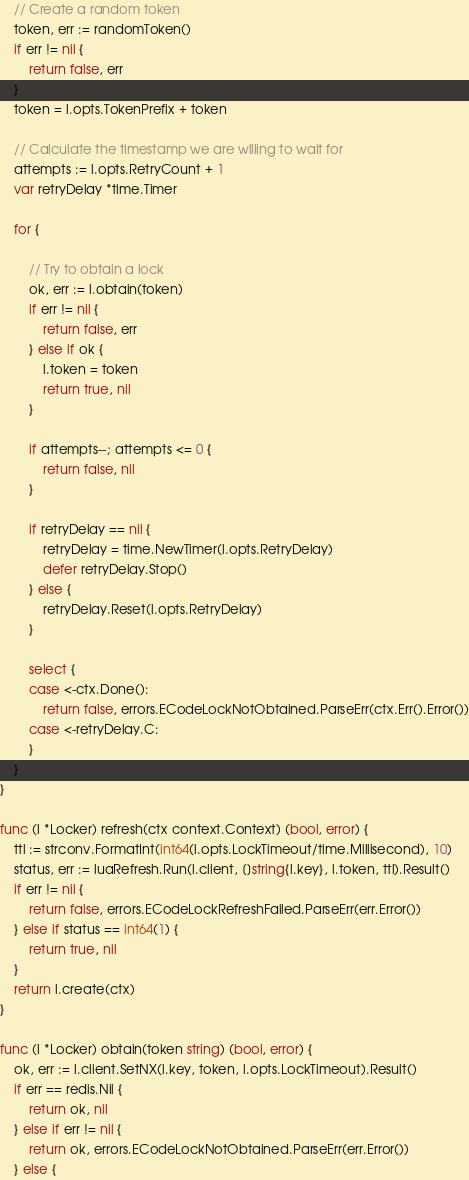<code> <loc_0><loc_0><loc_500><loc_500><_Go_>	// Create a random token
	token, err := randomToken()
	if err != nil {
		return false, err
	}
	token = l.opts.TokenPrefix + token

	// Calculate the timestamp we are willing to wait for
	attempts := l.opts.RetryCount + 1
	var retryDelay *time.Timer

	for {

		// Try to obtain a lock
		ok, err := l.obtain(token)
		if err != nil {
			return false, err
		} else if ok {
			l.token = token
			return true, nil
		}

		if attempts--; attempts <= 0 {
			return false, nil
		}

		if retryDelay == nil {
			retryDelay = time.NewTimer(l.opts.RetryDelay)
			defer retryDelay.Stop()
		} else {
			retryDelay.Reset(l.opts.RetryDelay)
		}

		select {
		case <-ctx.Done():
			return false, errors.ECodeLockNotObtained.ParseErr(ctx.Err().Error())
		case <-retryDelay.C:
		}
	}
}

func (l *Locker) refresh(ctx context.Context) (bool, error) {
	ttl := strconv.FormatInt(int64(l.opts.LockTimeout/time.Millisecond), 10)
	status, err := luaRefresh.Run(l.client, []string{l.key}, l.token, ttl).Result()
	if err != nil {
		return false, errors.ECodeLockRefreshFailed.ParseErr(err.Error())
	} else if status == int64(1) {
		return true, nil
	}
	return l.create(ctx)
}

func (l *Locker) obtain(token string) (bool, error) {
	ok, err := l.client.SetNX(l.key, token, l.opts.LockTimeout).Result()
	if err == redis.Nil {
		return ok, nil
	} else if err != nil {
		return ok, errors.ECodeLockNotObtained.ParseErr(err.Error())
	} else {</code> 